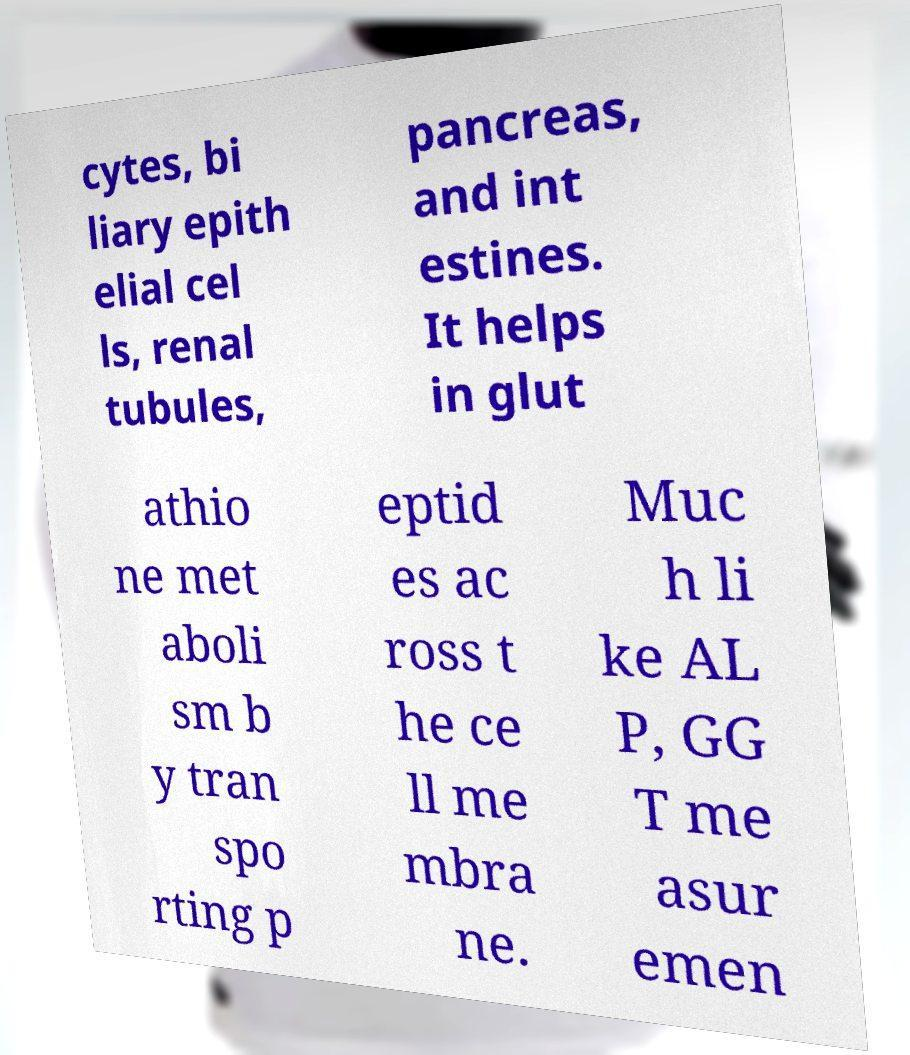Can you read and provide the text displayed in the image?This photo seems to have some interesting text. Can you extract and type it out for me? cytes, bi liary epith elial cel ls, renal tubules, pancreas, and int estines. It helps in glut athio ne met aboli sm b y tran spo rting p eptid es ac ross t he ce ll me mbra ne. Muc h li ke AL P, GG T me asur emen 